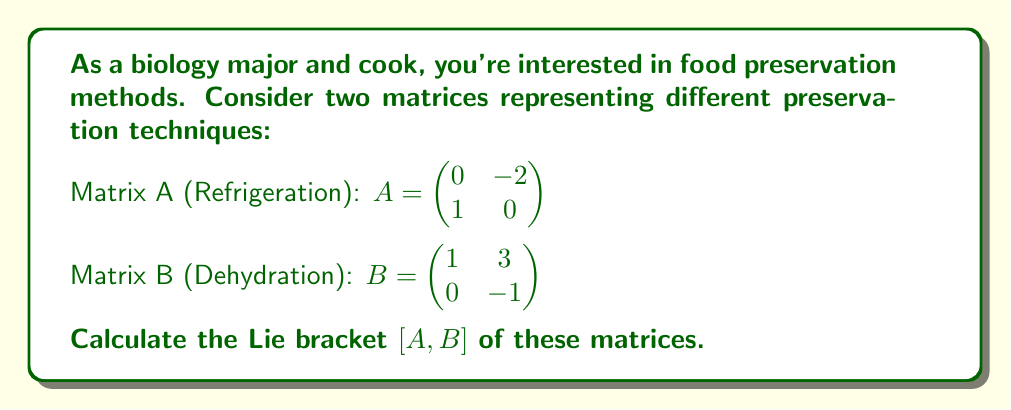Help me with this question. To calculate the Lie bracket $[A,B]$, we use the formula:

$[A,B] = AB - BA$

Step 1: Calculate AB
$$AB = \begin{pmatrix} 0 & -2 \\ 1 & 0 \end{pmatrix} \begin{pmatrix} 1 & 3 \\ 0 & -1 \end{pmatrix} = \begin{pmatrix} 0 & 2 \\ 1 & 3 \end{pmatrix}$$

Step 2: Calculate BA
$$BA = \begin{pmatrix} 1 & 3 \\ 0 & -1 \end{pmatrix} \begin{pmatrix} 0 & -2 \\ 1 & 0 \end{pmatrix} = \begin{pmatrix} 3 & -2 \\ -1 & 2 \end{pmatrix}$$

Step 3: Subtract BA from AB
$$[A,B] = AB - BA = \begin{pmatrix} 0 & 2 \\ 1 & 3 \end{pmatrix} - \begin{pmatrix} 3 & -2 \\ -1 & 2 \end{pmatrix} = \begin{pmatrix} -3 & 4 \\ 2 & 1 \end{pmatrix}$$
Answer: $[A,B] = \begin{pmatrix} -3 & 4 \\ 2 & 1 \end{pmatrix}$ 